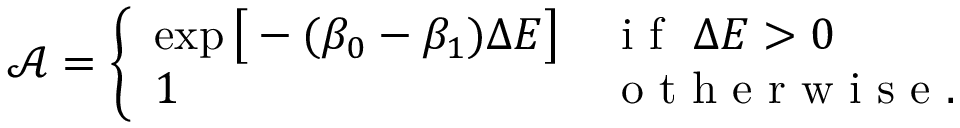Convert formula to latex. <formula><loc_0><loc_0><loc_500><loc_500>\mathcal { A } = \left \{ \begin{array} { l l } { \exp \left [ - ( \beta _ { 0 } - \beta _ { 1 } ) \Delta E \right ] } & { i f \ \Delta E > 0 } \\ { 1 } & { o t h e r w i s e . } \end{array}</formula> 